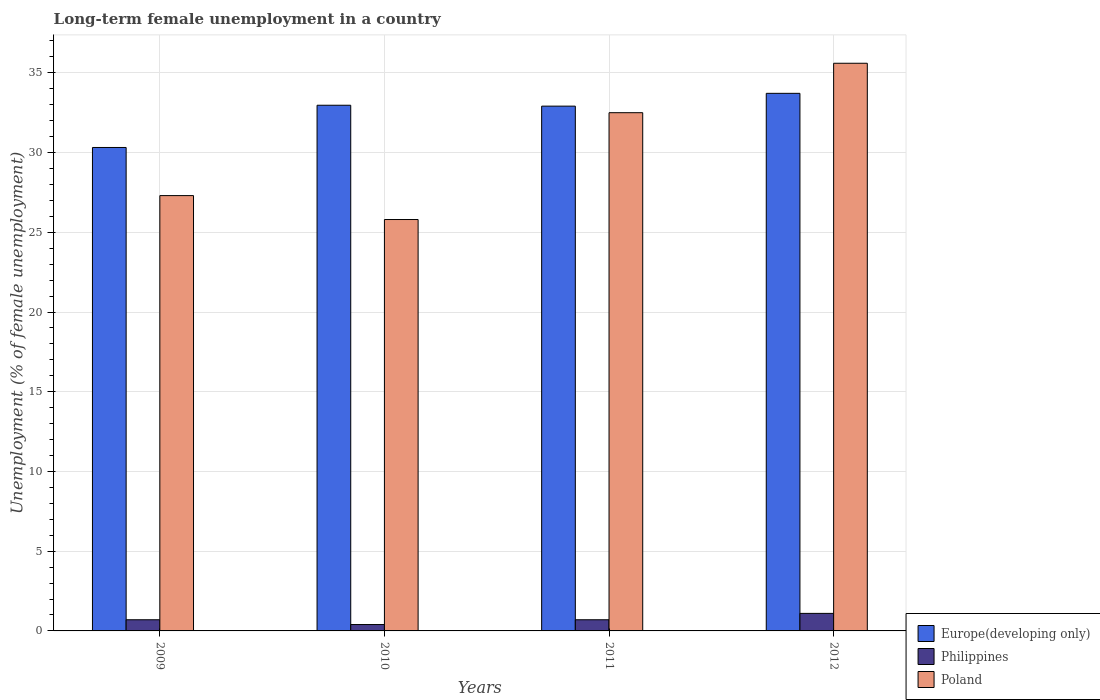How many different coloured bars are there?
Your response must be concise. 3. Are the number of bars per tick equal to the number of legend labels?
Provide a succinct answer. Yes. Are the number of bars on each tick of the X-axis equal?
Provide a succinct answer. Yes. How many bars are there on the 3rd tick from the right?
Your answer should be very brief. 3. In how many cases, is the number of bars for a given year not equal to the number of legend labels?
Your response must be concise. 0. What is the percentage of long-term unemployed female population in Philippines in 2010?
Give a very brief answer. 0.4. Across all years, what is the maximum percentage of long-term unemployed female population in Philippines?
Provide a succinct answer. 1.1. Across all years, what is the minimum percentage of long-term unemployed female population in Europe(developing only)?
Keep it short and to the point. 30.32. In which year was the percentage of long-term unemployed female population in Philippines minimum?
Keep it short and to the point. 2010. What is the total percentage of long-term unemployed female population in Poland in the graph?
Your answer should be very brief. 121.2. What is the difference between the percentage of long-term unemployed female population in Poland in 2009 and that in 2012?
Your answer should be compact. -8.3. What is the difference between the percentage of long-term unemployed female population in Europe(developing only) in 2011 and the percentage of long-term unemployed female population in Poland in 2010?
Offer a very short reply. 7.11. What is the average percentage of long-term unemployed female population in Philippines per year?
Make the answer very short. 0.73. In the year 2009, what is the difference between the percentage of long-term unemployed female population in Philippines and percentage of long-term unemployed female population in Poland?
Ensure brevity in your answer.  -26.6. What is the ratio of the percentage of long-term unemployed female population in Poland in 2009 to that in 2012?
Provide a succinct answer. 0.77. Is the percentage of long-term unemployed female population in Poland in 2009 less than that in 2010?
Your answer should be very brief. No. Is the difference between the percentage of long-term unemployed female population in Philippines in 2009 and 2010 greater than the difference between the percentage of long-term unemployed female population in Poland in 2009 and 2010?
Offer a very short reply. No. What is the difference between the highest and the second highest percentage of long-term unemployed female population in Poland?
Provide a short and direct response. 3.1. What is the difference between the highest and the lowest percentage of long-term unemployed female population in Philippines?
Make the answer very short. 0.7. In how many years, is the percentage of long-term unemployed female population in Philippines greater than the average percentage of long-term unemployed female population in Philippines taken over all years?
Offer a very short reply. 1. How many bars are there?
Provide a succinct answer. 12. Are all the bars in the graph horizontal?
Make the answer very short. No. Are the values on the major ticks of Y-axis written in scientific E-notation?
Your response must be concise. No. Where does the legend appear in the graph?
Make the answer very short. Bottom right. What is the title of the graph?
Keep it short and to the point. Long-term female unemployment in a country. Does "Congo (Democratic)" appear as one of the legend labels in the graph?
Your answer should be compact. No. What is the label or title of the Y-axis?
Your response must be concise. Unemployment (% of female unemployment). What is the Unemployment (% of female unemployment) of Europe(developing only) in 2009?
Your answer should be very brief. 30.32. What is the Unemployment (% of female unemployment) of Philippines in 2009?
Ensure brevity in your answer.  0.7. What is the Unemployment (% of female unemployment) of Poland in 2009?
Your answer should be compact. 27.3. What is the Unemployment (% of female unemployment) in Europe(developing only) in 2010?
Offer a terse response. 32.97. What is the Unemployment (% of female unemployment) in Philippines in 2010?
Give a very brief answer. 0.4. What is the Unemployment (% of female unemployment) in Poland in 2010?
Provide a succinct answer. 25.8. What is the Unemployment (% of female unemployment) in Europe(developing only) in 2011?
Your answer should be compact. 32.91. What is the Unemployment (% of female unemployment) in Philippines in 2011?
Provide a short and direct response. 0.7. What is the Unemployment (% of female unemployment) in Poland in 2011?
Offer a terse response. 32.5. What is the Unemployment (% of female unemployment) of Europe(developing only) in 2012?
Provide a short and direct response. 33.71. What is the Unemployment (% of female unemployment) of Philippines in 2012?
Make the answer very short. 1.1. What is the Unemployment (% of female unemployment) of Poland in 2012?
Make the answer very short. 35.6. Across all years, what is the maximum Unemployment (% of female unemployment) of Europe(developing only)?
Offer a very short reply. 33.71. Across all years, what is the maximum Unemployment (% of female unemployment) of Philippines?
Your response must be concise. 1.1. Across all years, what is the maximum Unemployment (% of female unemployment) in Poland?
Your answer should be compact. 35.6. Across all years, what is the minimum Unemployment (% of female unemployment) of Europe(developing only)?
Give a very brief answer. 30.32. Across all years, what is the minimum Unemployment (% of female unemployment) of Philippines?
Your response must be concise. 0.4. Across all years, what is the minimum Unemployment (% of female unemployment) in Poland?
Make the answer very short. 25.8. What is the total Unemployment (% of female unemployment) in Europe(developing only) in the graph?
Ensure brevity in your answer.  129.91. What is the total Unemployment (% of female unemployment) in Poland in the graph?
Make the answer very short. 121.2. What is the difference between the Unemployment (% of female unemployment) in Europe(developing only) in 2009 and that in 2010?
Provide a short and direct response. -2.65. What is the difference between the Unemployment (% of female unemployment) in Poland in 2009 and that in 2010?
Your response must be concise. 1.5. What is the difference between the Unemployment (% of female unemployment) in Europe(developing only) in 2009 and that in 2011?
Give a very brief answer. -2.59. What is the difference between the Unemployment (% of female unemployment) of Philippines in 2009 and that in 2011?
Keep it short and to the point. 0. What is the difference between the Unemployment (% of female unemployment) of Poland in 2009 and that in 2011?
Your response must be concise. -5.2. What is the difference between the Unemployment (% of female unemployment) in Europe(developing only) in 2009 and that in 2012?
Your answer should be very brief. -3.4. What is the difference between the Unemployment (% of female unemployment) of Poland in 2009 and that in 2012?
Give a very brief answer. -8.3. What is the difference between the Unemployment (% of female unemployment) in Europe(developing only) in 2010 and that in 2011?
Make the answer very short. 0.06. What is the difference between the Unemployment (% of female unemployment) of Europe(developing only) in 2010 and that in 2012?
Ensure brevity in your answer.  -0.75. What is the difference between the Unemployment (% of female unemployment) of Poland in 2010 and that in 2012?
Your answer should be compact. -9.8. What is the difference between the Unemployment (% of female unemployment) of Europe(developing only) in 2011 and that in 2012?
Your answer should be compact. -0.8. What is the difference between the Unemployment (% of female unemployment) in Poland in 2011 and that in 2012?
Offer a very short reply. -3.1. What is the difference between the Unemployment (% of female unemployment) of Europe(developing only) in 2009 and the Unemployment (% of female unemployment) of Philippines in 2010?
Offer a terse response. 29.92. What is the difference between the Unemployment (% of female unemployment) in Europe(developing only) in 2009 and the Unemployment (% of female unemployment) in Poland in 2010?
Provide a succinct answer. 4.52. What is the difference between the Unemployment (% of female unemployment) of Philippines in 2009 and the Unemployment (% of female unemployment) of Poland in 2010?
Give a very brief answer. -25.1. What is the difference between the Unemployment (% of female unemployment) of Europe(developing only) in 2009 and the Unemployment (% of female unemployment) of Philippines in 2011?
Ensure brevity in your answer.  29.62. What is the difference between the Unemployment (% of female unemployment) in Europe(developing only) in 2009 and the Unemployment (% of female unemployment) in Poland in 2011?
Make the answer very short. -2.18. What is the difference between the Unemployment (% of female unemployment) of Philippines in 2009 and the Unemployment (% of female unemployment) of Poland in 2011?
Offer a terse response. -31.8. What is the difference between the Unemployment (% of female unemployment) of Europe(developing only) in 2009 and the Unemployment (% of female unemployment) of Philippines in 2012?
Ensure brevity in your answer.  29.22. What is the difference between the Unemployment (% of female unemployment) in Europe(developing only) in 2009 and the Unemployment (% of female unemployment) in Poland in 2012?
Provide a short and direct response. -5.28. What is the difference between the Unemployment (% of female unemployment) of Philippines in 2009 and the Unemployment (% of female unemployment) of Poland in 2012?
Give a very brief answer. -34.9. What is the difference between the Unemployment (% of female unemployment) in Europe(developing only) in 2010 and the Unemployment (% of female unemployment) in Philippines in 2011?
Keep it short and to the point. 32.27. What is the difference between the Unemployment (% of female unemployment) of Europe(developing only) in 2010 and the Unemployment (% of female unemployment) of Poland in 2011?
Keep it short and to the point. 0.47. What is the difference between the Unemployment (% of female unemployment) in Philippines in 2010 and the Unemployment (% of female unemployment) in Poland in 2011?
Make the answer very short. -32.1. What is the difference between the Unemployment (% of female unemployment) of Europe(developing only) in 2010 and the Unemployment (% of female unemployment) of Philippines in 2012?
Give a very brief answer. 31.87. What is the difference between the Unemployment (% of female unemployment) in Europe(developing only) in 2010 and the Unemployment (% of female unemployment) in Poland in 2012?
Offer a very short reply. -2.63. What is the difference between the Unemployment (% of female unemployment) in Philippines in 2010 and the Unemployment (% of female unemployment) in Poland in 2012?
Ensure brevity in your answer.  -35.2. What is the difference between the Unemployment (% of female unemployment) in Europe(developing only) in 2011 and the Unemployment (% of female unemployment) in Philippines in 2012?
Ensure brevity in your answer.  31.81. What is the difference between the Unemployment (% of female unemployment) in Europe(developing only) in 2011 and the Unemployment (% of female unemployment) in Poland in 2012?
Make the answer very short. -2.69. What is the difference between the Unemployment (% of female unemployment) in Philippines in 2011 and the Unemployment (% of female unemployment) in Poland in 2012?
Provide a succinct answer. -34.9. What is the average Unemployment (% of female unemployment) in Europe(developing only) per year?
Keep it short and to the point. 32.48. What is the average Unemployment (% of female unemployment) in Philippines per year?
Your answer should be very brief. 0.72. What is the average Unemployment (% of female unemployment) in Poland per year?
Your answer should be very brief. 30.3. In the year 2009, what is the difference between the Unemployment (% of female unemployment) in Europe(developing only) and Unemployment (% of female unemployment) in Philippines?
Your answer should be very brief. 29.62. In the year 2009, what is the difference between the Unemployment (% of female unemployment) in Europe(developing only) and Unemployment (% of female unemployment) in Poland?
Keep it short and to the point. 3.02. In the year 2009, what is the difference between the Unemployment (% of female unemployment) of Philippines and Unemployment (% of female unemployment) of Poland?
Give a very brief answer. -26.6. In the year 2010, what is the difference between the Unemployment (% of female unemployment) of Europe(developing only) and Unemployment (% of female unemployment) of Philippines?
Your answer should be very brief. 32.57. In the year 2010, what is the difference between the Unemployment (% of female unemployment) of Europe(developing only) and Unemployment (% of female unemployment) of Poland?
Offer a terse response. 7.17. In the year 2010, what is the difference between the Unemployment (% of female unemployment) of Philippines and Unemployment (% of female unemployment) of Poland?
Your response must be concise. -25.4. In the year 2011, what is the difference between the Unemployment (% of female unemployment) in Europe(developing only) and Unemployment (% of female unemployment) in Philippines?
Offer a terse response. 32.21. In the year 2011, what is the difference between the Unemployment (% of female unemployment) of Europe(developing only) and Unemployment (% of female unemployment) of Poland?
Ensure brevity in your answer.  0.41. In the year 2011, what is the difference between the Unemployment (% of female unemployment) of Philippines and Unemployment (% of female unemployment) of Poland?
Ensure brevity in your answer.  -31.8. In the year 2012, what is the difference between the Unemployment (% of female unemployment) of Europe(developing only) and Unemployment (% of female unemployment) of Philippines?
Offer a very short reply. 32.61. In the year 2012, what is the difference between the Unemployment (% of female unemployment) in Europe(developing only) and Unemployment (% of female unemployment) in Poland?
Give a very brief answer. -1.89. In the year 2012, what is the difference between the Unemployment (% of female unemployment) in Philippines and Unemployment (% of female unemployment) in Poland?
Provide a succinct answer. -34.5. What is the ratio of the Unemployment (% of female unemployment) of Europe(developing only) in 2009 to that in 2010?
Offer a terse response. 0.92. What is the ratio of the Unemployment (% of female unemployment) of Philippines in 2009 to that in 2010?
Provide a short and direct response. 1.75. What is the ratio of the Unemployment (% of female unemployment) in Poland in 2009 to that in 2010?
Provide a short and direct response. 1.06. What is the ratio of the Unemployment (% of female unemployment) of Europe(developing only) in 2009 to that in 2011?
Your answer should be very brief. 0.92. What is the ratio of the Unemployment (% of female unemployment) in Philippines in 2009 to that in 2011?
Provide a succinct answer. 1. What is the ratio of the Unemployment (% of female unemployment) in Poland in 2009 to that in 2011?
Offer a terse response. 0.84. What is the ratio of the Unemployment (% of female unemployment) of Europe(developing only) in 2009 to that in 2012?
Give a very brief answer. 0.9. What is the ratio of the Unemployment (% of female unemployment) of Philippines in 2009 to that in 2012?
Make the answer very short. 0.64. What is the ratio of the Unemployment (% of female unemployment) in Poland in 2009 to that in 2012?
Provide a succinct answer. 0.77. What is the ratio of the Unemployment (% of female unemployment) of Europe(developing only) in 2010 to that in 2011?
Your answer should be very brief. 1. What is the ratio of the Unemployment (% of female unemployment) of Philippines in 2010 to that in 2011?
Make the answer very short. 0.57. What is the ratio of the Unemployment (% of female unemployment) of Poland in 2010 to that in 2011?
Make the answer very short. 0.79. What is the ratio of the Unemployment (% of female unemployment) of Europe(developing only) in 2010 to that in 2012?
Your response must be concise. 0.98. What is the ratio of the Unemployment (% of female unemployment) of Philippines in 2010 to that in 2012?
Give a very brief answer. 0.36. What is the ratio of the Unemployment (% of female unemployment) of Poland in 2010 to that in 2012?
Your response must be concise. 0.72. What is the ratio of the Unemployment (% of female unemployment) in Europe(developing only) in 2011 to that in 2012?
Make the answer very short. 0.98. What is the ratio of the Unemployment (% of female unemployment) of Philippines in 2011 to that in 2012?
Ensure brevity in your answer.  0.64. What is the ratio of the Unemployment (% of female unemployment) of Poland in 2011 to that in 2012?
Your answer should be very brief. 0.91. What is the difference between the highest and the second highest Unemployment (% of female unemployment) in Europe(developing only)?
Make the answer very short. 0.75. What is the difference between the highest and the second highest Unemployment (% of female unemployment) in Philippines?
Your response must be concise. 0.4. What is the difference between the highest and the lowest Unemployment (% of female unemployment) in Europe(developing only)?
Keep it short and to the point. 3.4. What is the difference between the highest and the lowest Unemployment (% of female unemployment) of Philippines?
Offer a terse response. 0.7. What is the difference between the highest and the lowest Unemployment (% of female unemployment) in Poland?
Offer a very short reply. 9.8. 